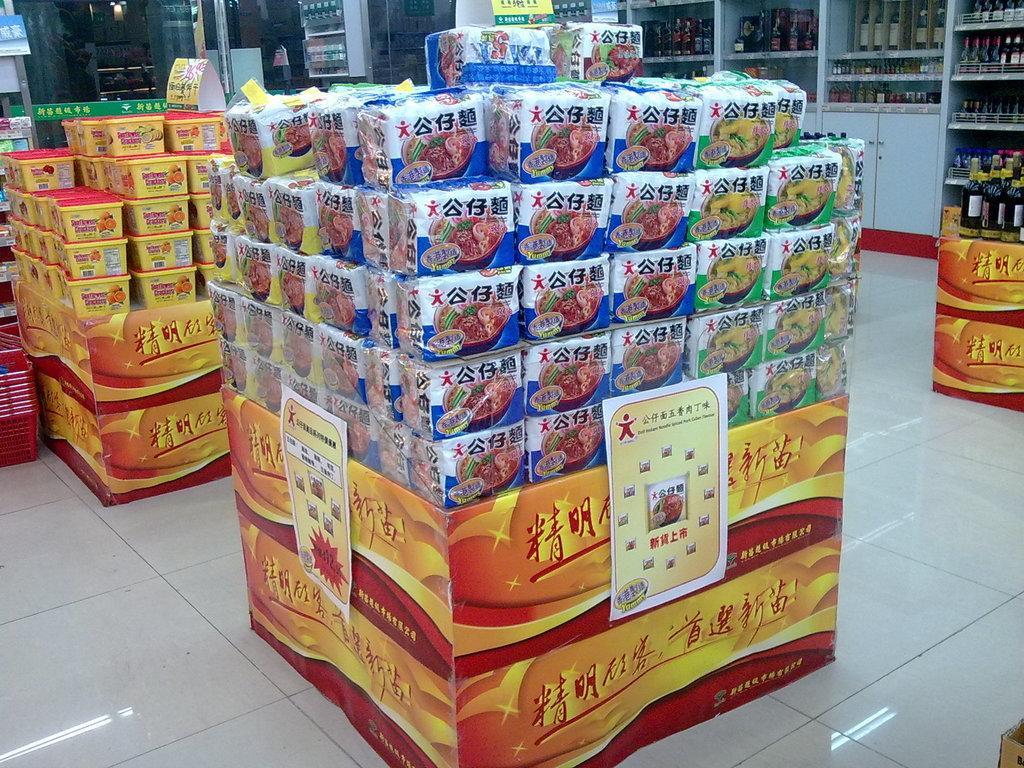Could you give a brief overview of what you see in this image? In this picture I can see the items in the plastic covers, on the left side there are boxes. In the background I can see the bottles on the shelves. It looks like a store. 